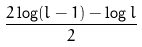Convert formula to latex. <formula><loc_0><loc_0><loc_500><loc_500>\frac { 2 \log ( l - 1 ) - \log l } { 2 }</formula> 